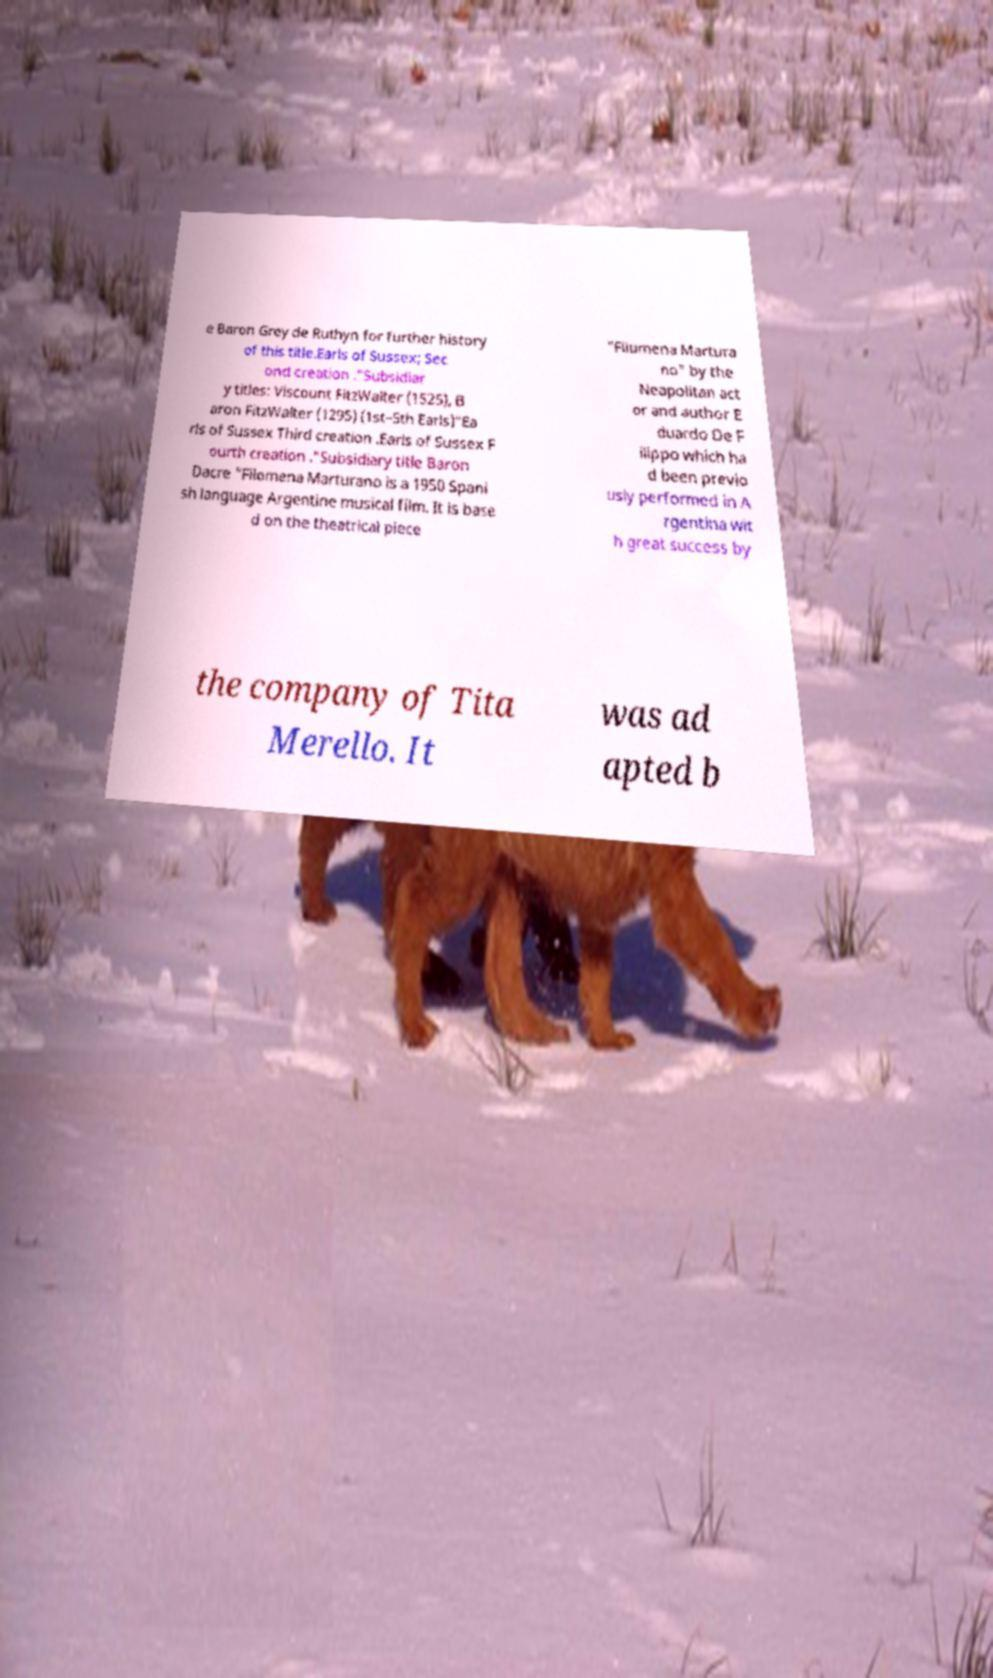Please read and relay the text visible in this image. What does it say? e Baron Grey de Ruthyn for further history of this title.Earls of Sussex; Sec ond creation ."Subsidiar y titles: Viscount FitzWalter (1525), B aron FitzWalter (1295) (1st–5th Earls)"Ea rls of Sussex Third creation .Earls of Sussex F ourth creation ."Subsidiary title Baron Dacre "Filomena Marturano is a 1950 Spani sh language Argentine musical film. It is base d on the theatrical piece "Filumena Martura no" by the Neapolitan act or and author E duardo De F ilippo which ha d been previo usly performed in A rgentina wit h great success by the company of Tita Merello. It was ad apted b 